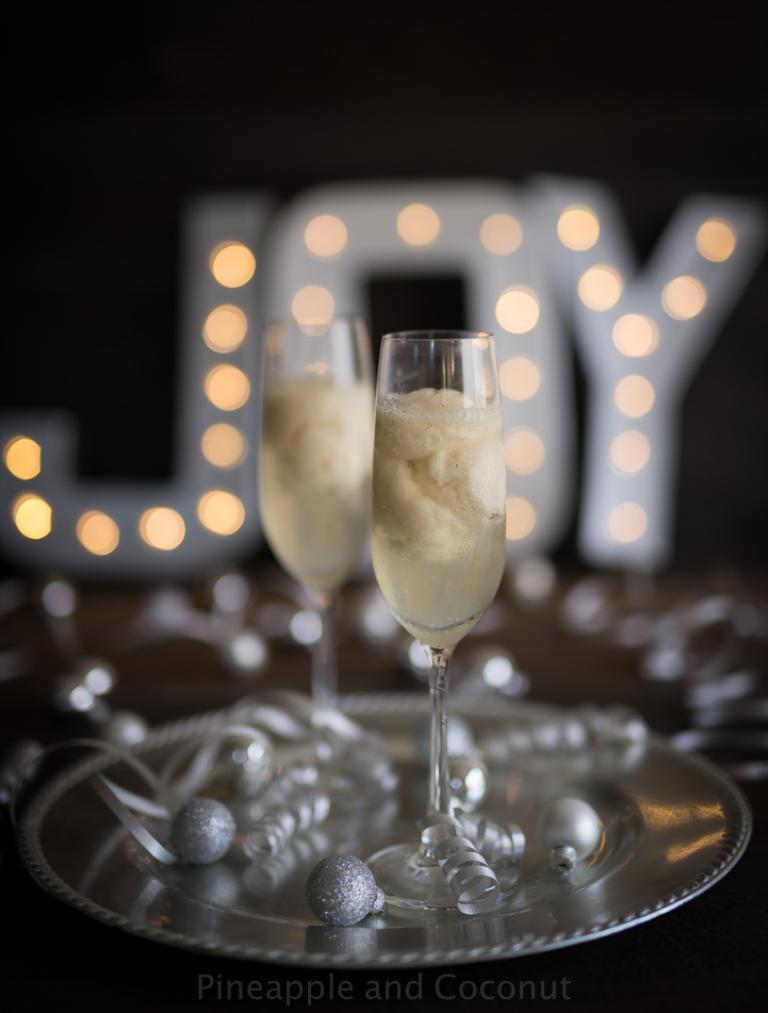What type of objects can be seen in the image? There are glasses and objects in a plate in the image. Can you describe the background of the image? The background of the image is blurred. What type of lighting is present in the image? There are letter boards with lights in the image. Where is the toothbrush located in the image? There is no toothbrush present in the image. What type of plant can be seen growing in the image? There is no plant visible in the image. 